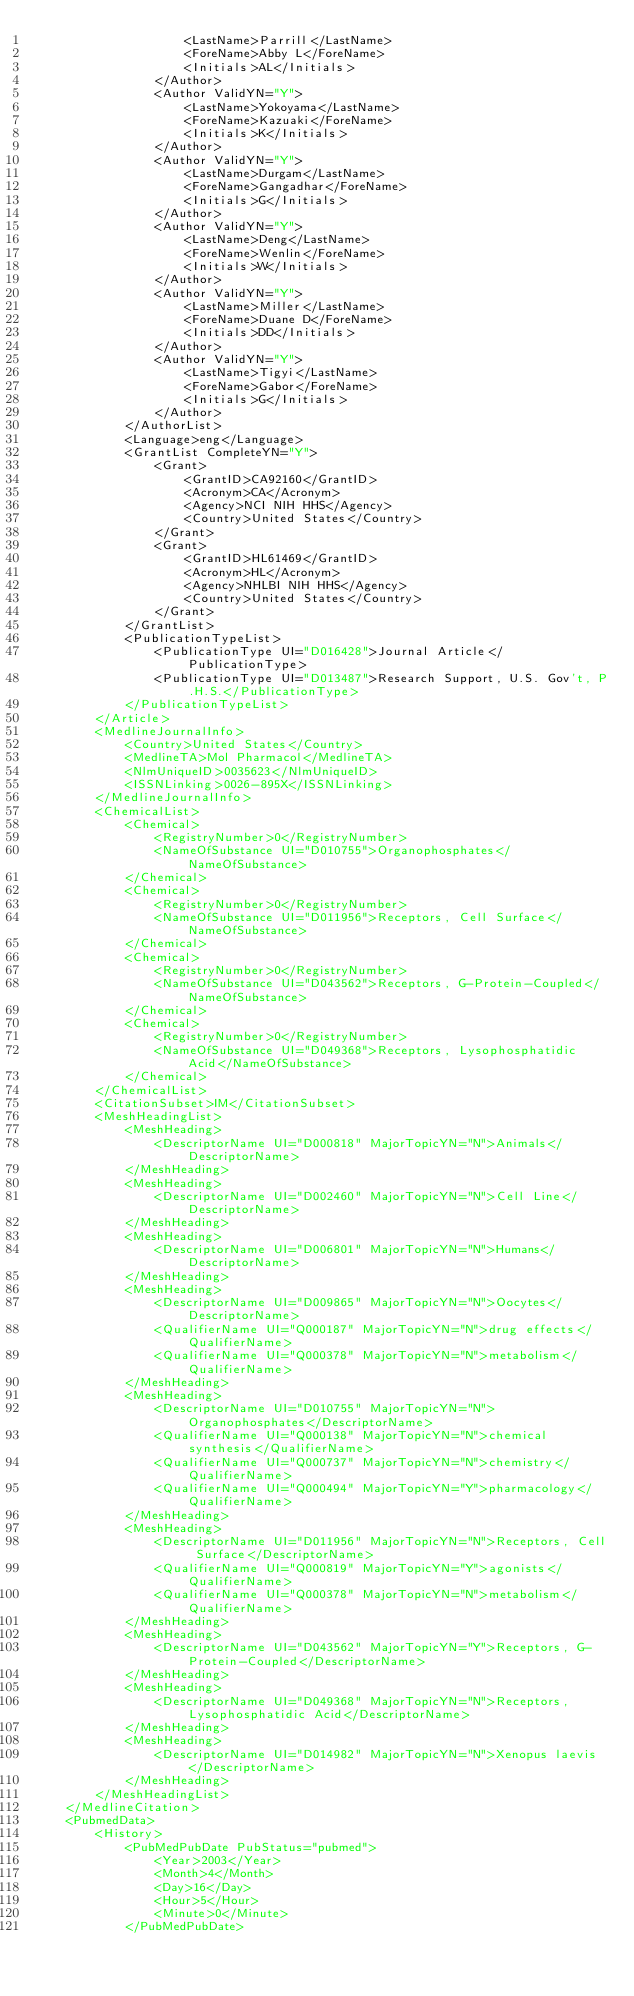Convert code to text. <code><loc_0><loc_0><loc_500><loc_500><_XML_>                    <LastName>Parrill</LastName>
                    <ForeName>Abby L</ForeName>
                    <Initials>AL</Initials>
                </Author>
                <Author ValidYN="Y">
                    <LastName>Yokoyama</LastName>
                    <ForeName>Kazuaki</ForeName>
                    <Initials>K</Initials>
                </Author>
                <Author ValidYN="Y">
                    <LastName>Durgam</LastName>
                    <ForeName>Gangadhar</ForeName>
                    <Initials>G</Initials>
                </Author>
                <Author ValidYN="Y">
                    <LastName>Deng</LastName>
                    <ForeName>Wenlin</ForeName>
                    <Initials>W</Initials>
                </Author>
                <Author ValidYN="Y">
                    <LastName>Miller</LastName>
                    <ForeName>Duane D</ForeName>
                    <Initials>DD</Initials>
                </Author>
                <Author ValidYN="Y">
                    <LastName>Tigyi</LastName>
                    <ForeName>Gabor</ForeName>
                    <Initials>G</Initials>
                </Author>
            </AuthorList>
            <Language>eng</Language>
            <GrantList CompleteYN="Y">
                <Grant>
                    <GrantID>CA92160</GrantID>
                    <Acronym>CA</Acronym>
                    <Agency>NCI NIH HHS</Agency>
                    <Country>United States</Country>
                </Grant>
                <Grant>
                    <GrantID>HL61469</GrantID>
                    <Acronym>HL</Acronym>
                    <Agency>NHLBI NIH HHS</Agency>
                    <Country>United States</Country>
                </Grant>
            </GrantList>
            <PublicationTypeList>
                <PublicationType UI="D016428">Journal Article</PublicationType>
                <PublicationType UI="D013487">Research Support, U.S. Gov't, P.H.S.</PublicationType>
            </PublicationTypeList>
        </Article>
        <MedlineJournalInfo>
            <Country>United States</Country>
            <MedlineTA>Mol Pharmacol</MedlineTA>
            <NlmUniqueID>0035623</NlmUniqueID>
            <ISSNLinking>0026-895X</ISSNLinking>
        </MedlineJournalInfo>
        <ChemicalList>
            <Chemical>
                <RegistryNumber>0</RegistryNumber>
                <NameOfSubstance UI="D010755">Organophosphates</NameOfSubstance>
            </Chemical>
            <Chemical>
                <RegistryNumber>0</RegistryNumber>
                <NameOfSubstance UI="D011956">Receptors, Cell Surface</NameOfSubstance>
            </Chemical>
            <Chemical>
                <RegistryNumber>0</RegistryNumber>
                <NameOfSubstance UI="D043562">Receptors, G-Protein-Coupled</NameOfSubstance>
            </Chemical>
            <Chemical>
                <RegistryNumber>0</RegistryNumber>
                <NameOfSubstance UI="D049368">Receptors, Lysophosphatidic Acid</NameOfSubstance>
            </Chemical>
        </ChemicalList>
        <CitationSubset>IM</CitationSubset>
        <MeshHeadingList>
            <MeshHeading>
                <DescriptorName UI="D000818" MajorTopicYN="N">Animals</DescriptorName>
            </MeshHeading>
            <MeshHeading>
                <DescriptorName UI="D002460" MajorTopicYN="N">Cell Line</DescriptorName>
            </MeshHeading>
            <MeshHeading>
                <DescriptorName UI="D006801" MajorTopicYN="N">Humans</DescriptorName>
            </MeshHeading>
            <MeshHeading>
                <DescriptorName UI="D009865" MajorTopicYN="N">Oocytes</DescriptorName>
                <QualifierName UI="Q000187" MajorTopicYN="N">drug effects</QualifierName>
                <QualifierName UI="Q000378" MajorTopicYN="N">metabolism</QualifierName>
            </MeshHeading>
            <MeshHeading>
                <DescriptorName UI="D010755" MajorTopicYN="N">Organophosphates</DescriptorName>
                <QualifierName UI="Q000138" MajorTopicYN="N">chemical synthesis</QualifierName>
                <QualifierName UI="Q000737" MajorTopicYN="N">chemistry</QualifierName>
                <QualifierName UI="Q000494" MajorTopicYN="Y">pharmacology</QualifierName>
            </MeshHeading>
            <MeshHeading>
                <DescriptorName UI="D011956" MajorTopicYN="N">Receptors, Cell Surface</DescriptorName>
                <QualifierName UI="Q000819" MajorTopicYN="Y">agonists</QualifierName>
                <QualifierName UI="Q000378" MajorTopicYN="N">metabolism</QualifierName>
            </MeshHeading>
            <MeshHeading>
                <DescriptorName UI="D043562" MajorTopicYN="Y">Receptors, G-Protein-Coupled</DescriptorName>
            </MeshHeading>
            <MeshHeading>
                <DescriptorName UI="D049368" MajorTopicYN="N">Receptors, Lysophosphatidic Acid</DescriptorName>
            </MeshHeading>
            <MeshHeading>
                <DescriptorName UI="D014982" MajorTopicYN="N">Xenopus laevis</DescriptorName>
            </MeshHeading>
        </MeshHeadingList>
    </MedlineCitation>
    <PubmedData>
        <History>
            <PubMedPubDate PubStatus="pubmed">
                <Year>2003</Year>
                <Month>4</Month>
                <Day>16</Day>
                <Hour>5</Hour>
                <Minute>0</Minute>
            </PubMedPubDate></code> 